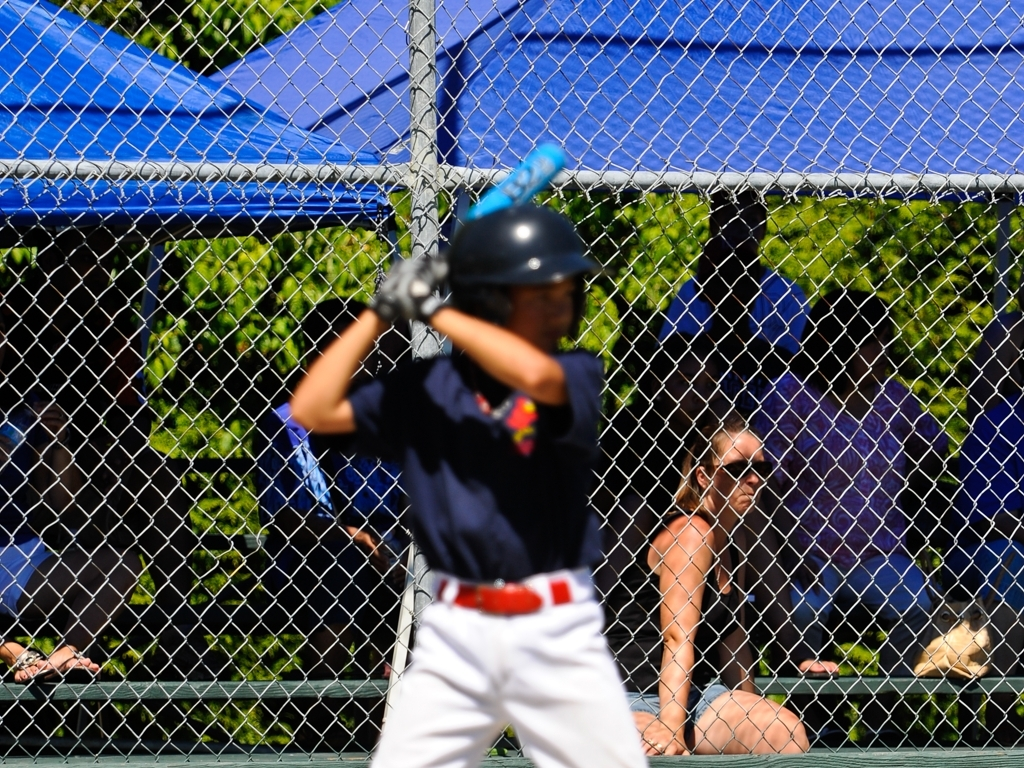What can be inferred about the game's progression from this image alone? Although specific details of the game's progression are not observable due to the blurred action and limited frame, the image does capture a critical moment, which is the batter preparing for or in the process of swinging. This suggest a live play is occurring, indicating that the game is underway rather than in a paused or preparatory stage. 